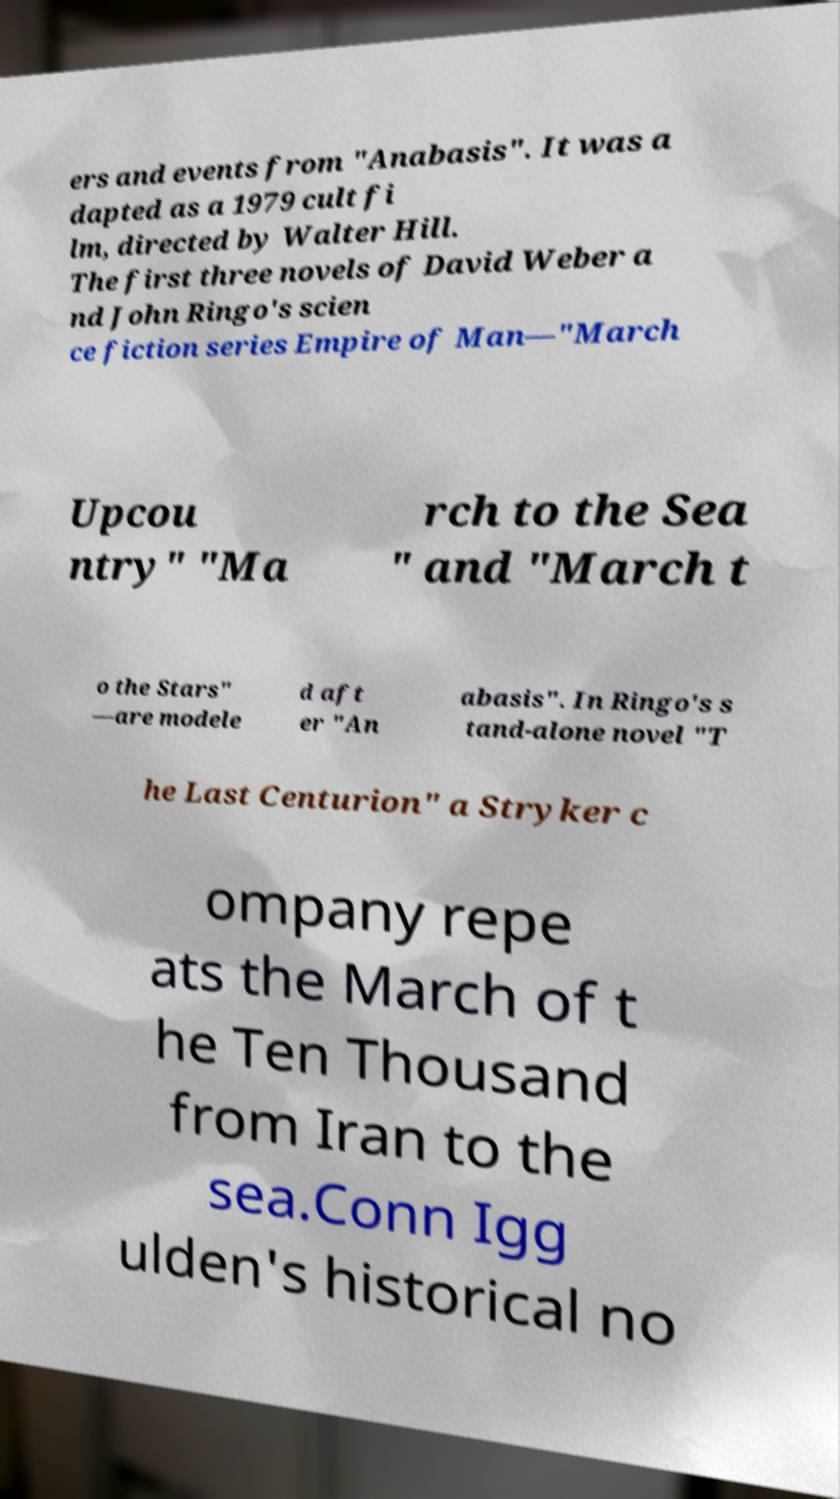I need the written content from this picture converted into text. Can you do that? ers and events from "Anabasis". It was a dapted as a 1979 cult fi lm, directed by Walter Hill. The first three novels of David Weber a nd John Ringo's scien ce fiction series Empire of Man—"March Upcou ntry" "Ma rch to the Sea " and "March t o the Stars" —are modele d aft er "An abasis". In Ringo's s tand-alone novel "T he Last Centurion" a Stryker c ompany repe ats the March of t he Ten Thousand from Iran to the sea.Conn Igg ulden's historical no 